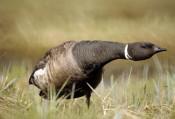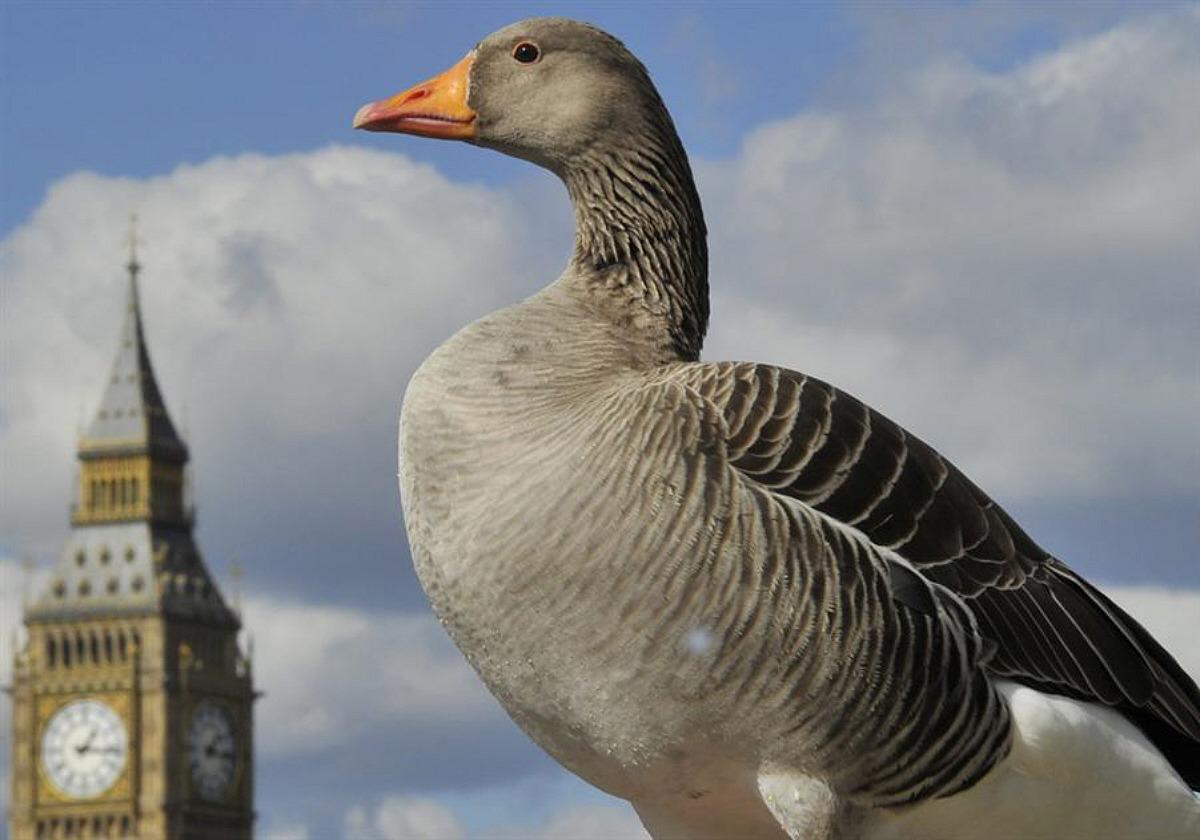The first image is the image on the left, the second image is the image on the right. Examine the images to the left and right. Is the description "Two geese are floating on the water in the image on the left." accurate? Answer yes or no. No. 